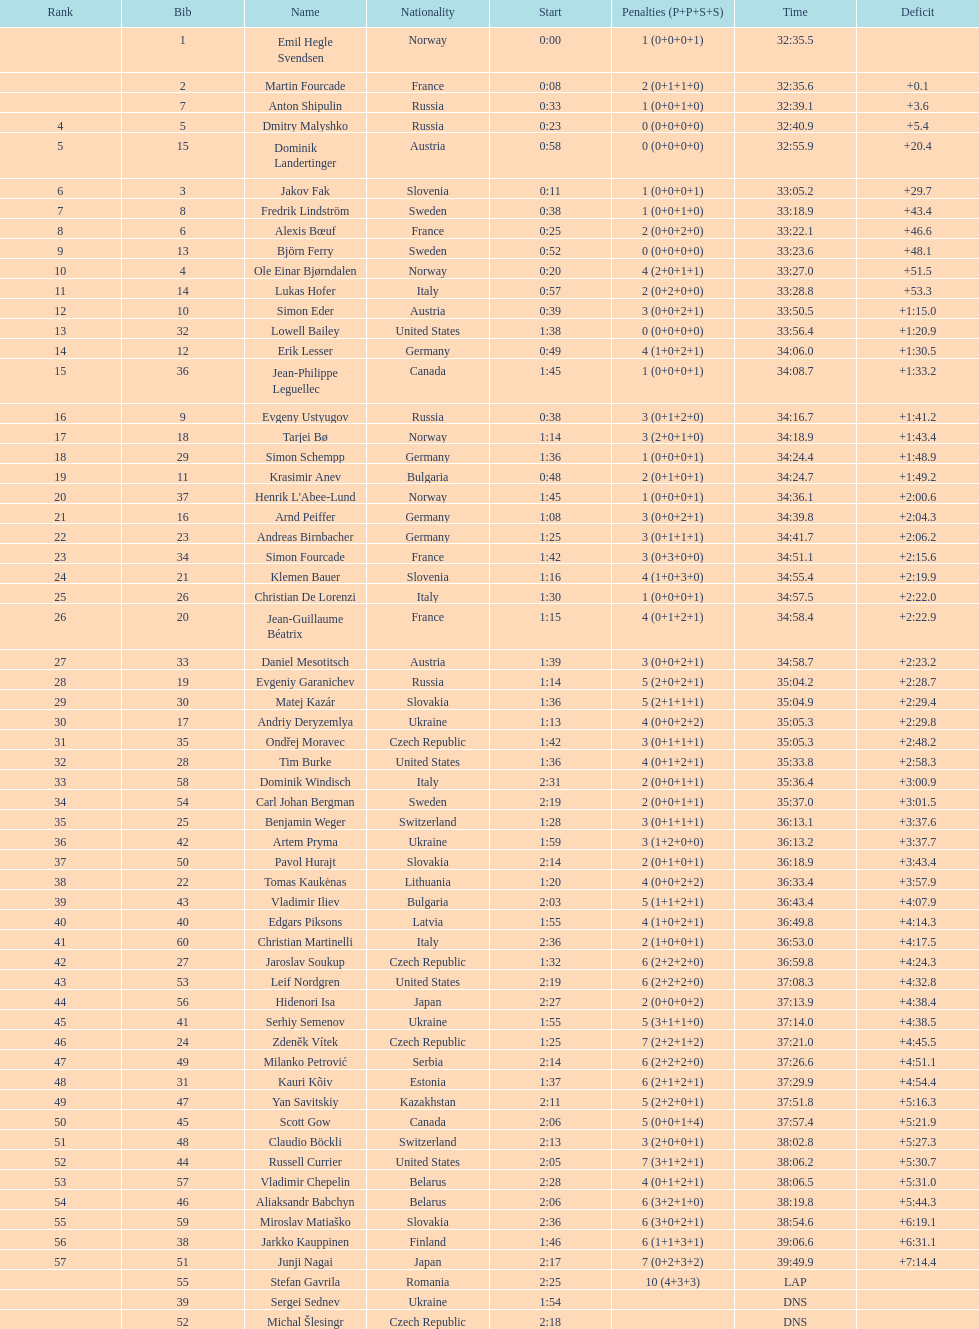Between bjorn ferry, simon elder and erik lesser - who had the most penalties? Erik Lesser. 